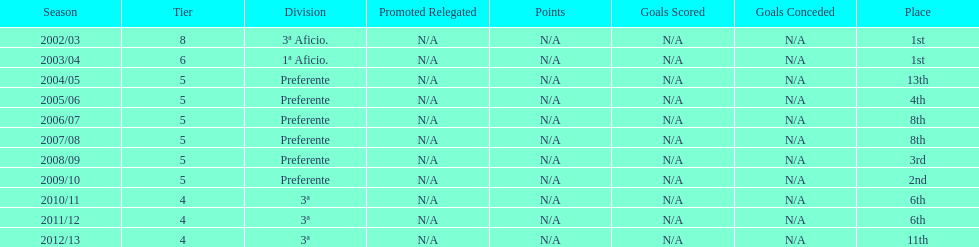How many years was the team in the 3 a division? 4. 